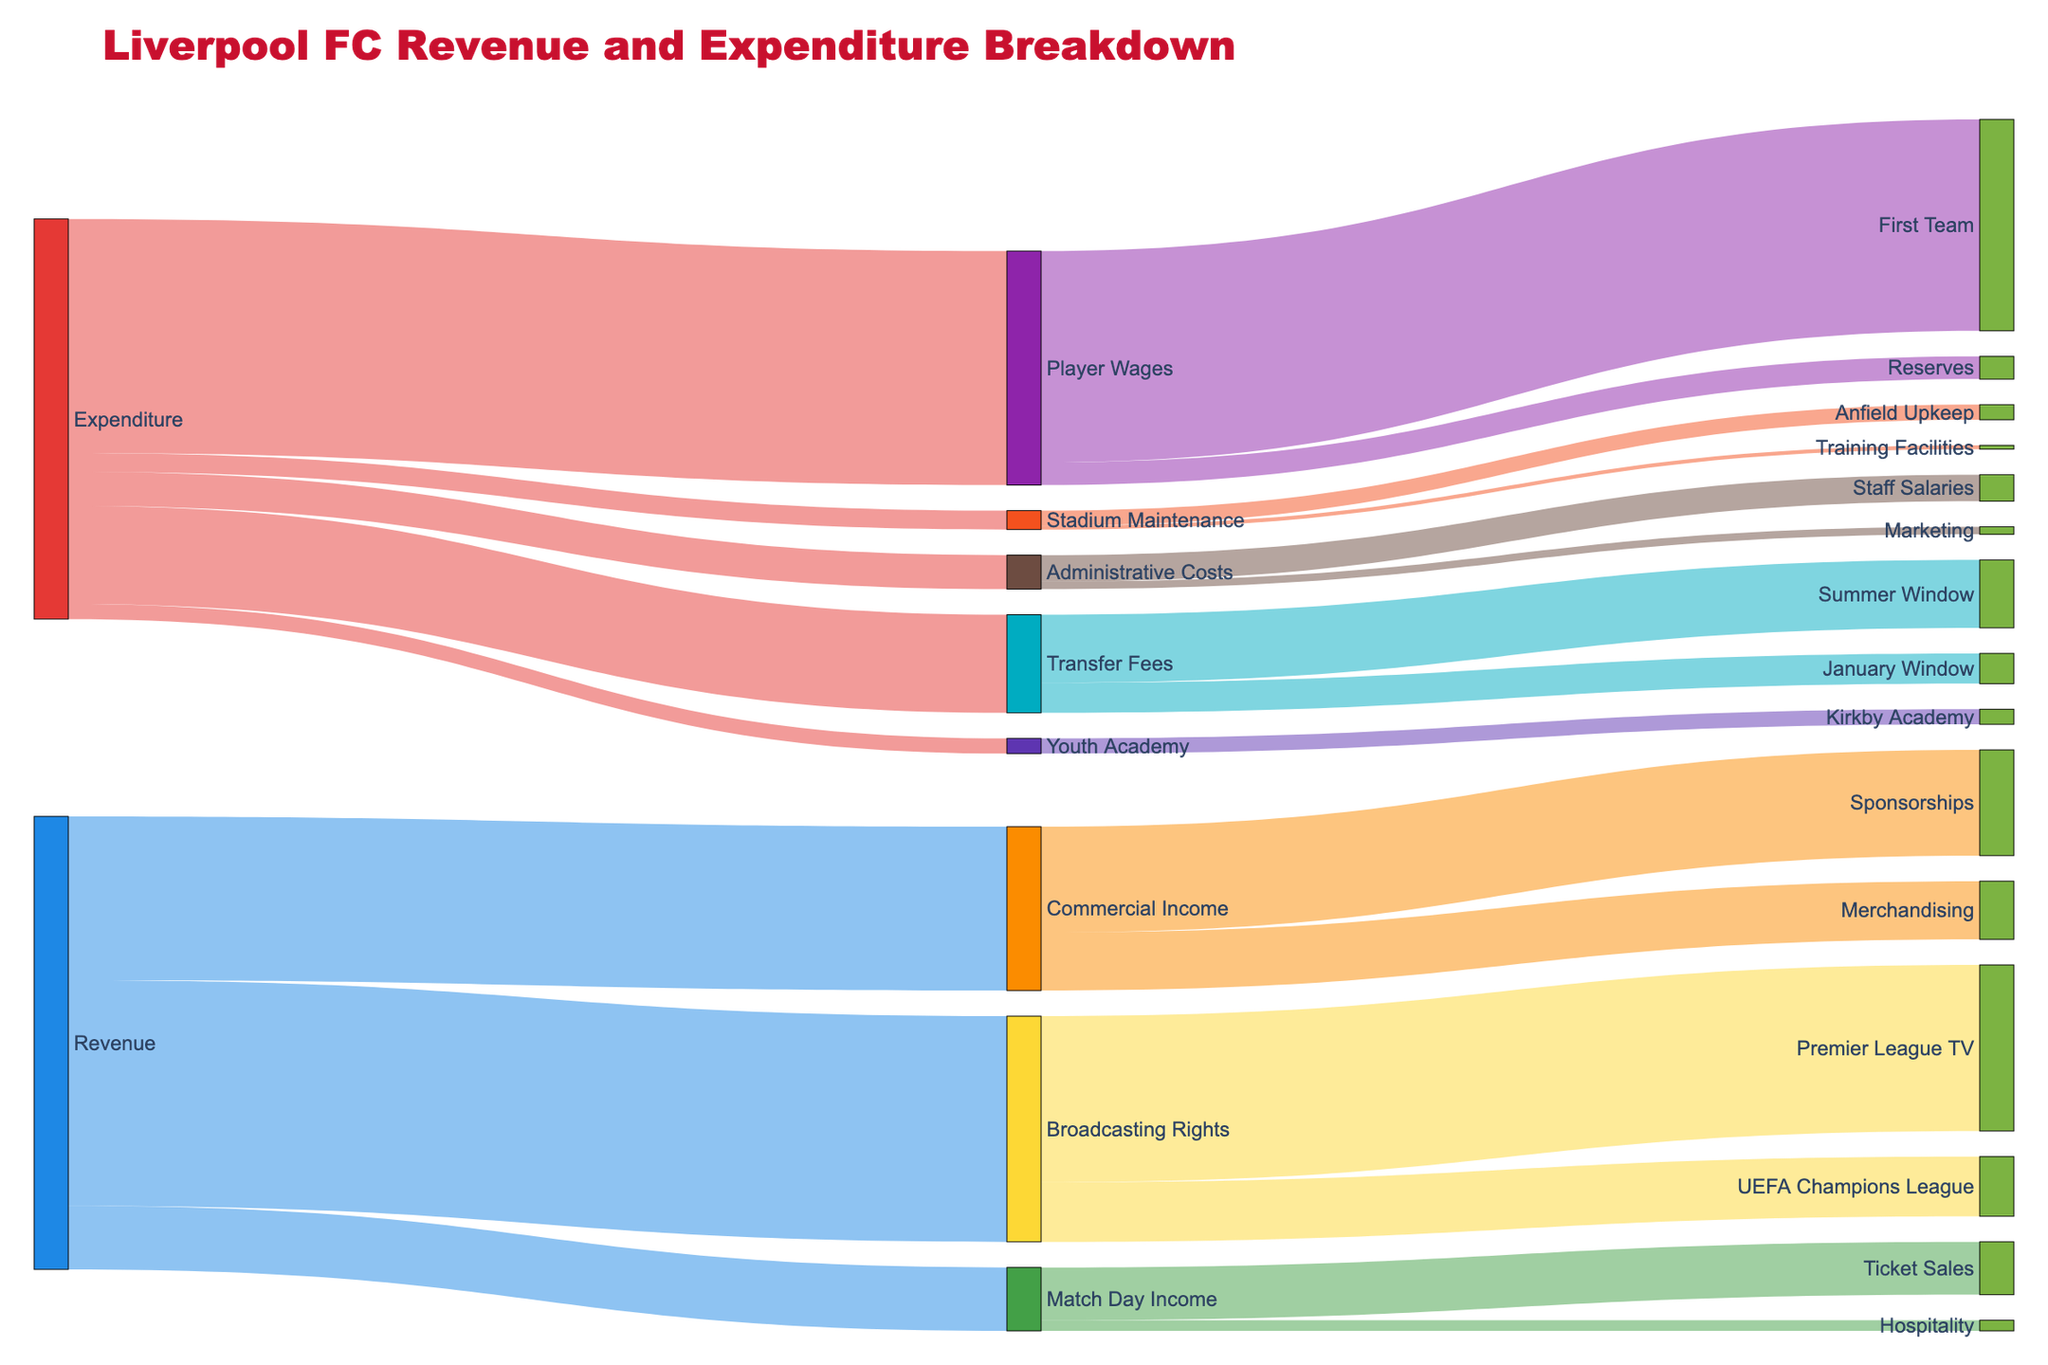what is the total revenue from Match Day Income, Broadcasting Rights, and Commercial Income? To find the total revenue, sum up the values of Match Day Income (84), Broadcasting Rights (299), and Commercial Income (217). The calculation is 84 + 299 + 217 = 600
Answer: 600 Which expenditure category has the highest value? Look at the values for each expenditure category: Player Wages (310), Transfer Fees (130), Stadium Maintenance (25), Youth Academy (20), and Administrative Costs (45). The highest value is 310 for Player Wages
Answer: Player Wages What is the relationship between Sponsorships and Merchandising within Commercial Income? Within Commercial Income, we have Sponsorships (140) and Merchandising (77). Sponsorships are greater than Merchandising, as 140 is greater than 77
Answer: Sponsorships are greater Which two sub-categories within Player Wages have contributions? Player Wages is divided into First Team (280) and Reserves (30)
Answer: First Team and Reserves What is the combined expenditure on both Stadium Maintenance and Youth Academy? To find the combined expenditure, sum the values of Stadium Maintenance (25) and Youth Academy (20). The calculation is 25 + 20 = 45
Answer: 45 How much does Liverpool FC spend on Marketing compared to Staff Salaries? Look at the values for Marketing (10) and Staff Salaries (35) within Administrative Costs. Marketing costs less, as 10 is less than 35
Answer: Marketing costs less What are the visual features used to differentiate between Revenue and Expenditure categories? Revenue categories are depicted with cool colors (blue, green, yellow), while Expenditure categories use warm colors (red, purple, orange). The node label font, node color, and link transparency also help differentiate.
Answer: Color variations and node labels What portion of Broadcasting Rights comes from the Premier League TV? Broadcasting Rights has a total value of 299, with Premier League TV contributing 220. To find the portion, calculate (220 / 299) * 100%. The calculation gives approximately 73.57%.
Answer: Approximately 73.57% Which category within Expenditure has the smallest value, and what is it? The values within Expenditure are Player Wages (310), Transfer Fees (130), Stadium Maintenance (25), Youth Academy (20), and Administrative Costs (45). The smallest value is Youth Academy with 20
Answer: Youth Academy, 20 How is Transfer Fees divided between Summer Window and January Window? Transfer Fees are divided into Summer Window (90) and January Window (40)
Answer: Summer Window and January Window 